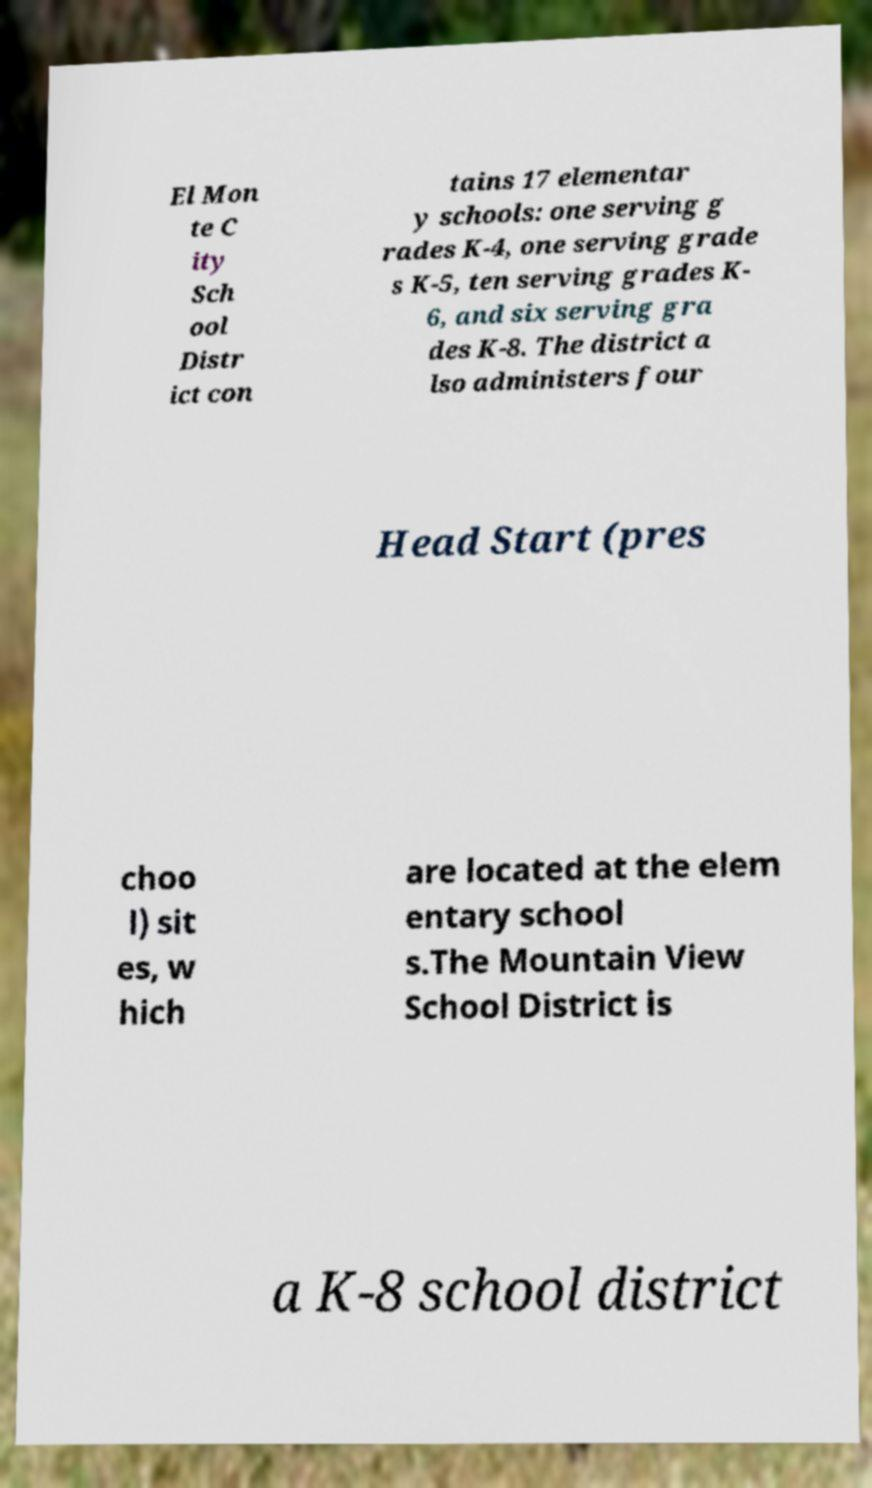Could you assist in decoding the text presented in this image and type it out clearly? El Mon te C ity Sch ool Distr ict con tains 17 elementar y schools: one serving g rades K-4, one serving grade s K-5, ten serving grades K- 6, and six serving gra des K-8. The district a lso administers four Head Start (pres choo l) sit es, w hich are located at the elem entary school s.The Mountain View School District is a K-8 school district 